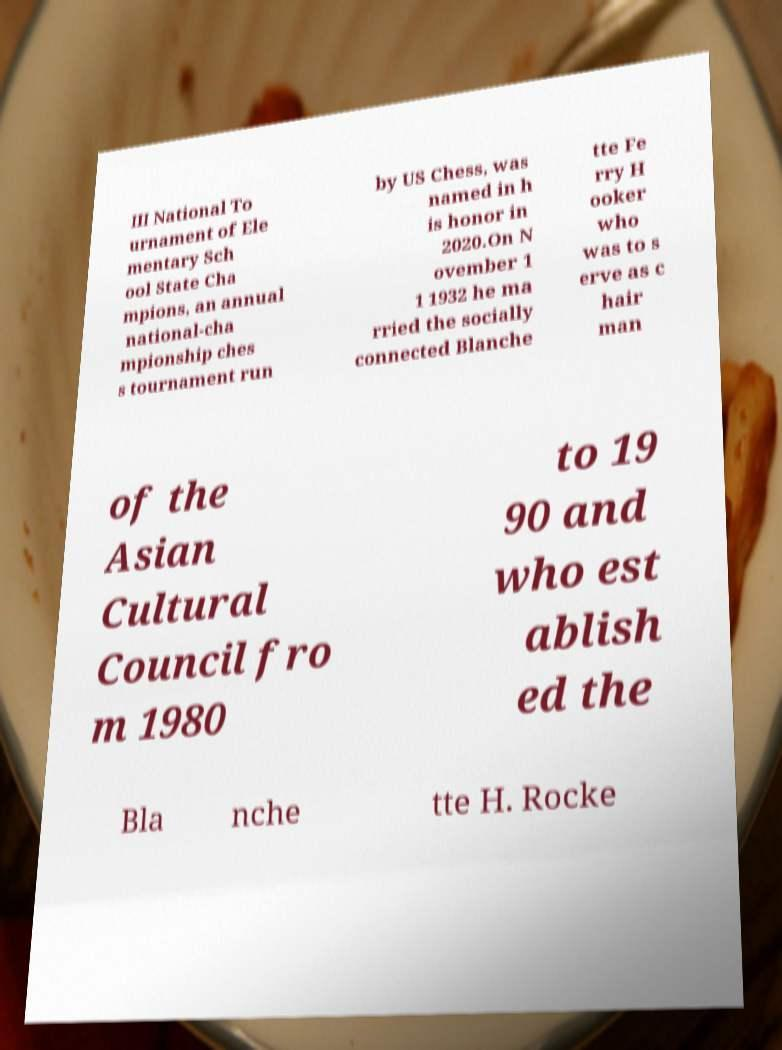Could you assist in decoding the text presented in this image and type it out clearly? III National To urnament of Ele mentary Sch ool State Cha mpions, an annual national-cha mpionship ches s tournament run by US Chess, was named in h is honor in 2020.On N ovember 1 1 1932 he ma rried the socially connected Blanche tte Fe rry H ooker who was to s erve as c hair man of the Asian Cultural Council fro m 1980 to 19 90 and who est ablish ed the Bla nche tte H. Rocke 